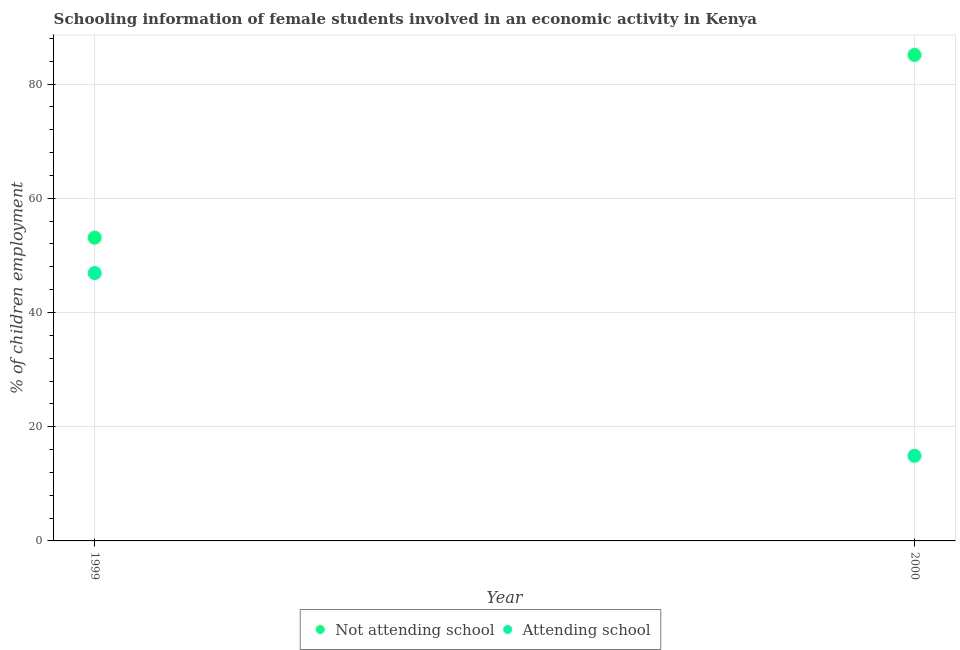Is the number of dotlines equal to the number of legend labels?
Your response must be concise. Yes. What is the percentage of employed females who are attending school in 1999?
Ensure brevity in your answer.  46.9. Across all years, what is the maximum percentage of employed females who are not attending school?
Your answer should be compact. 85.1. Across all years, what is the minimum percentage of employed females who are attending school?
Offer a terse response. 14.9. In which year was the percentage of employed females who are not attending school minimum?
Keep it short and to the point. 1999. What is the total percentage of employed females who are not attending school in the graph?
Ensure brevity in your answer.  138.2. What is the difference between the percentage of employed females who are not attending school in 1999 and that in 2000?
Give a very brief answer. -32. What is the difference between the percentage of employed females who are not attending school in 1999 and the percentage of employed females who are attending school in 2000?
Provide a succinct answer. 38.2. What is the average percentage of employed females who are not attending school per year?
Ensure brevity in your answer.  69.1. In the year 1999, what is the difference between the percentage of employed females who are attending school and percentage of employed females who are not attending school?
Offer a very short reply. -6.2. What is the ratio of the percentage of employed females who are attending school in 1999 to that in 2000?
Provide a succinct answer. 3.15. In how many years, is the percentage of employed females who are not attending school greater than the average percentage of employed females who are not attending school taken over all years?
Make the answer very short. 1. Is the percentage of employed females who are not attending school strictly greater than the percentage of employed females who are attending school over the years?
Your response must be concise. Yes. What is the difference between two consecutive major ticks on the Y-axis?
Make the answer very short. 20. Does the graph contain any zero values?
Your response must be concise. No. Does the graph contain grids?
Keep it short and to the point. Yes. Where does the legend appear in the graph?
Your answer should be very brief. Bottom center. How are the legend labels stacked?
Your response must be concise. Horizontal. What is the title of the graph?
Keep it short and to the point. Schooling information of female students involved in an economic activity in Kenya. Does "Investment in Telecom" appear as one of the legend labels in the graph?
Your response must be concise. No. What is the label or title of the X-axis?
Your answer should be compact. Year. What is the label or title of the Y-axis?
Make the answer very short. % of children employment. What is the % of children employment in Not attending school in 1999?
Keep it short and to the point. 53.1. What is the % of children employment of Attending school in 1999?
Give a very brief answer. 46.9. What is the % of children employment of Not attending school in 2000?
Provide a succinct answer. 85.1. Across all years, what is the maximum % of children employment in Not attending school?
Your answer should be compact. 85.1. Across all years, what is the maximum % of children employment in Attending school?
Make the answer very short. 46.9. Across all years, what is the minimum % of children employment of Not attending school?
Make the answer very short. 53.1. Across all years, what is the minimum % of children employment in Attending school?
Your response must be concise. 14.9. What is the total % of children employment of Not attending school in the graph?
Keep it short and to the point. 138.2. What is the total % of children employment of Attending school in the graph?
Offer a very short reply. 61.8. What is the difference between the % of children employment of Not attending school in 1999 and that in 2000?
Offer a terse response. -32. What is the difference between the % of children employment of Not attending school in 1999 and the % of children employment of Attending school in 2000?
Give a very brief answer. 38.2. What is the average % of children employment of Not attending school per year?
Your answer should be very brief. 69.1. What is the average % of children employment in Attending school per year?
Offer a terse response. 30.9. In the year 1999, what is the difference between the % of children employment of Not attending school and % of children employment of Attending school?
Your answer should be compact. 6.2. In the year 2000, what is the difference between the % of children employment in Not attending school and % of children employment in Attending school?
Keep it short and to the point. 70.2. What is the ratio of the % of children employment of Not attending school in 1999 to that in 2000?
Keep it short and to the point. 0.62. What is the ratio of the % of children employment of Attending school in 1999 to that in 2000?
Your answer should be very brief. 3.15. What is the difference between the highest and the second highest % of children employment of Not attending school?
Give a very brief answer. 32. What is the difference between the highest and the second highest % of children employment of Attending school?
Provide a short and direct response. 32. What is the difference between the highest and the lowest % of children employment in Attending school?
Your response must be concise. 32. 